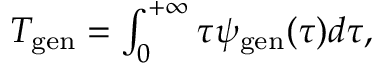<formula> <loc_0><loc_0><loc_500><loc_500>\begin{array} { r } { T _ { g e n } = \int _ { 0 } ^ { + \infty } { \tau \psi _ { g e n } ( \tau ) d \tau } , } \end{array}</formula> 